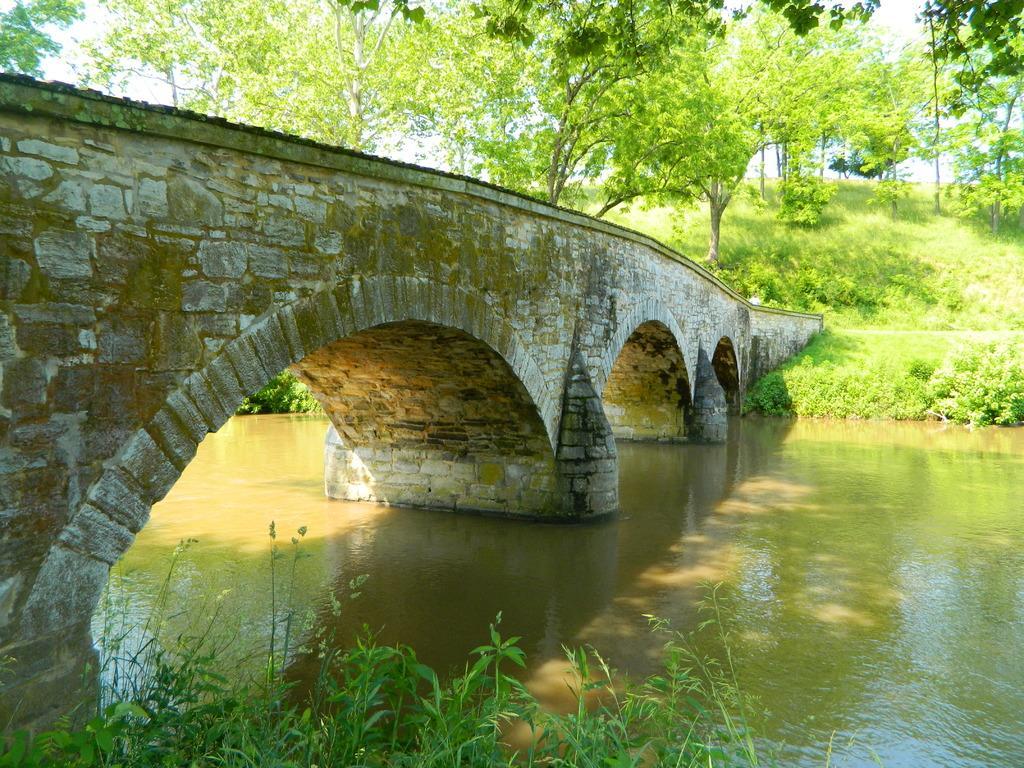Please provide a concise description of this image. In this image I can see water, a bridge, grass, number of trees and shadows. 